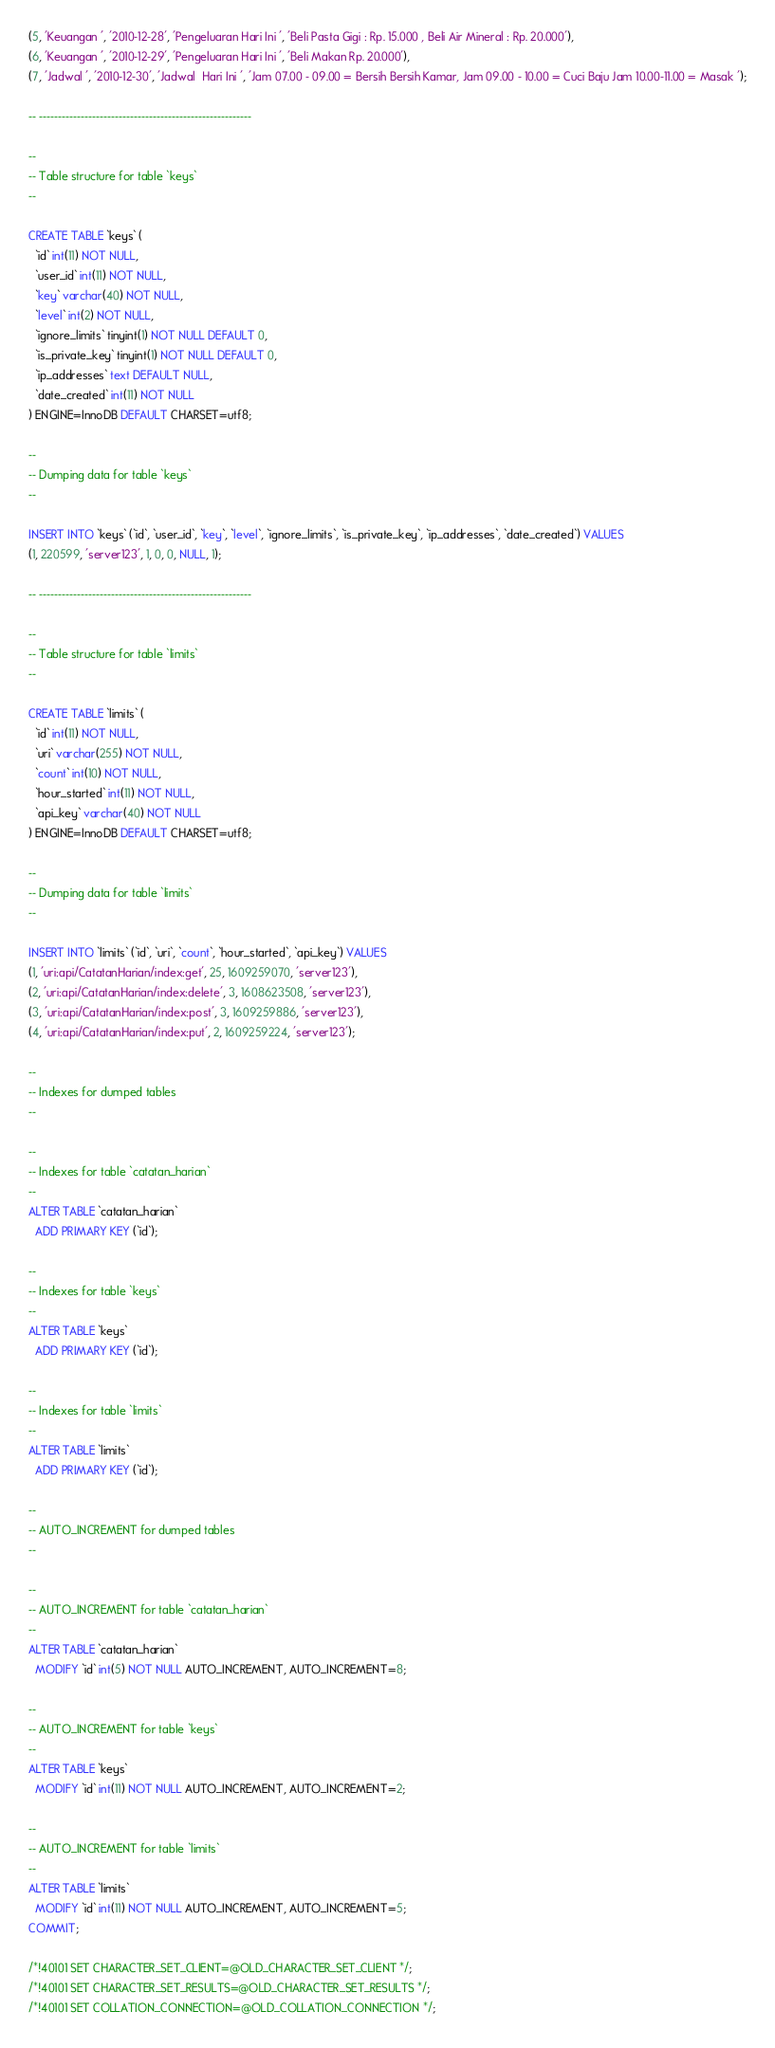Convert code to text. <code><loc_0><loc_0><loc_500><loc_500><_SQL_>(5, 'Keuangan ', '2010-12-28', 'Pengeluaran Hari Ini ', 'Beli Pasta Gigi : Rp. 15.000 , Beli Air Mineral : Rp. 20.000'),
(6, 'Keuangan ', '2010-12-29', 'Pengeluaran Hari Ini ', 'Beli Makan Rp. 20.000'),
(7, 'Jadwal ', '2010-12-30', 'Jadwal  Hari Ini ', 'Jam 07.00 - 09.00 = Bersih Bersih Kamar, Jam 09.00 - 10.00 = Cuci Baju Jam 10.00-11.00 = Masak ');

-- --------------------------------------------------------

--
-- Table structure for table `keys`
--

CREATE TABLE `keys` (
  `id` int(11) NOT NULL,
  `user_id` int(11) NOT NULL,
  `key` varchar(40) NOT NULL,
  `level` int(2) NOT NULL,
  `ignore_limits` tinyint(1) NOT NULL DEFAULT 0,
  `is_private_key` tinyint(1) NOT NULL DEFAULT 0,
  `ip_addresses` text DEFAULT NULL,
  `date_created` int(11) NOT NULL
) ENGINE=InnoDB DEFAULT CHARSET=utf8;

--
-- Dumping data for table `keys`
--

INSERT INTO `keys` (`id`, `user_id`, `key`, `level`, `ignore_limits`, `is_private_key`, `ip_addresses`, `date_created`) VALUES
(1, 220599, 'server123', 1, 0, 0, NULL, 1);

-- --------------------------------------------------------

--
-- Table structure for table `limits`
--

CREATE TABLE `limits` (
  `id` int(11) NOT NULL,
  `uri` varchar(255) NOT NULL,
  `count` int(10) NOT NULL,
  `hour_started` int(11) NOT NULL,
  `api_key` varchar(40) NOT NULL
) ENGINE=InnoDB DEFAULT CHARSET=utf8;

--
-- Dumping data for table `limits`
--

INSERT INTO `limits` (`id`, `uri`, `count`, `hour_started`, `api_key`) VALUES
(1, 'uri:api/CatatanHarian/index:get', 25, 1609259070, 'server123'),
(2, 'uri:api/CatatanHarian/index:delete', 3, 1608623508, 'server123'),
(3, 'uri:api/CatatanHarian/index:post', 3, 1609259886, 'server123'),
(4, 'uri:api/CatatanHarian/index:put', 2, 1609259224, 'server123');

--
-- Indexes for dumped tables
--

--
-- Indexes for table `catatan_harian`
--
ALTER TABLE `catatan_harian`
  ADD PRIMARY KEY (`id`);

--
-- Indexes for table `keys`
--
ALTER TABLE `keys`
  ADD PRIMARY KEY (`id`);

--
-- Indexes for table `limits`
--
ALTER TABLE `limits`
  ADD PRIMARY KEY (`id`);

--
-- AUTO_INCREMENT for dumped tables
--

--
-- AUTO_INCREMENT for table `catatan_harian`
--
ALTER TABLE `catatan_harian`
  MODIFY `id` int(5) NOT NULL AUTO_INCREMENT, AUTO_INCREMENT=8;

--
-- AUTO_INCREMENT for table `keys`
--
ALTER TABLE `keys`
  MODIFY `id` int(11) NOT NULL AUTO_INCREMENT, AUTO_INCREMENT=2;

--
-- AUTO_INCREMENT for table `limits`
--
ALTER TABLE `limits`
  MODIFY `id` int(11) NOT NULL AUTO_INCREMENT, AUTO_INCREMENT=5;
COMMIT;

/*!40101 SET CHARACTER_SET_CLIENT=@OLD_CHARACTER_SET_CLIENT */;
/*!40101 SET CHARACTER_SET_RESULTS=@OLD_CHARACTER_SET_RESULTS */;
/*!40101 SET COLLATION_CONNECTION=@OLD_COLLATION_CONNECTION */;
</code> 